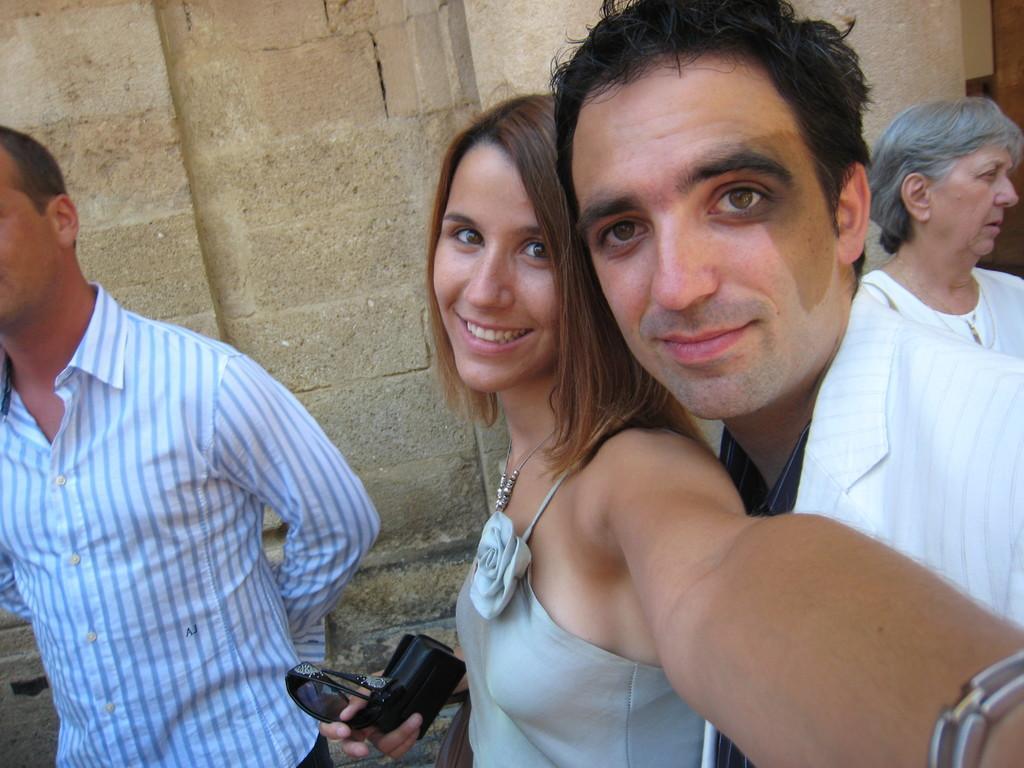How would you summarize this image in a sentence or two? In this image I can see group of people standing. The person in front wearing white color shirt and the other person wearing gray color dress. Background I can see wall in cream color. 